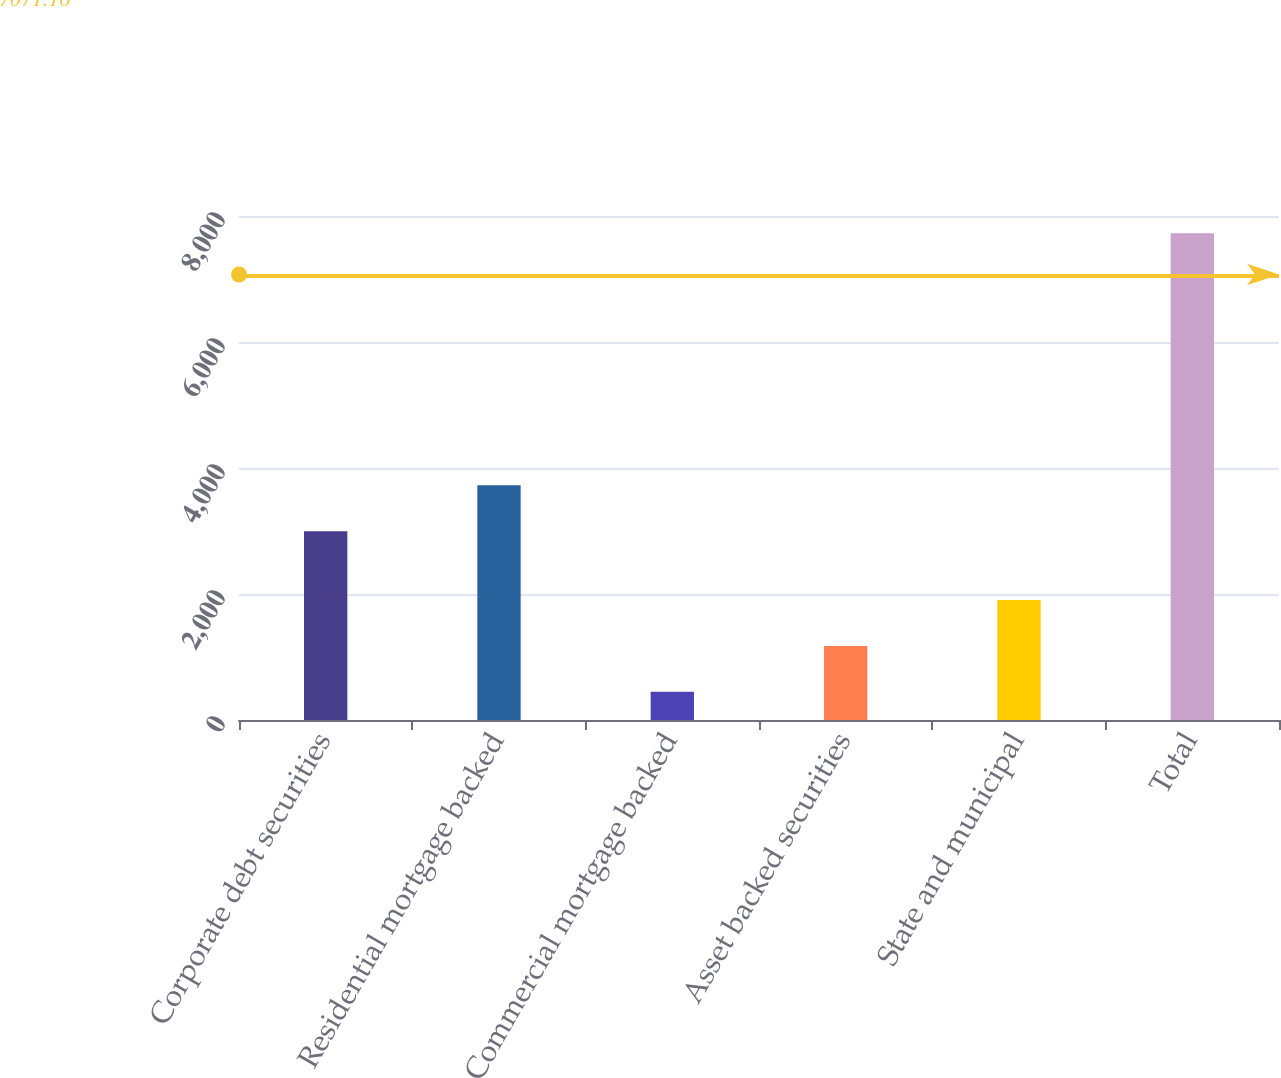Convert chart to OTSL. <chart><loc_0><loc_0><loc_500><loc_500><bar_chart><fcel>Corporate debt securities<fcel>Residential mortgage backed<fcel>Commercial mortgage backed<fcel>Asset backed securities<fcel>State and municipal<fcel>Total<nl><fcel>2998<fcel>3725.9<fcel>448<fcel>1175.9<fcel>1903.8<fcel>7727<nl></chart> 